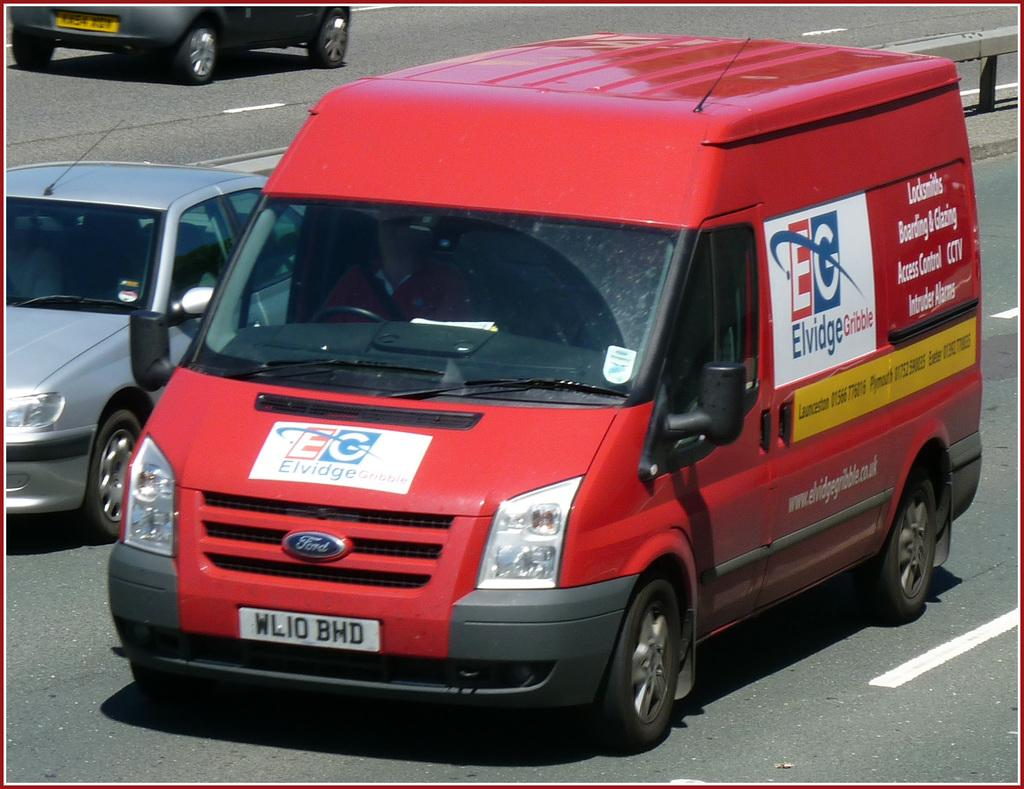<image>
Create a compact narrative representing the image presented. A Ford Elvidge van drives down the road. 